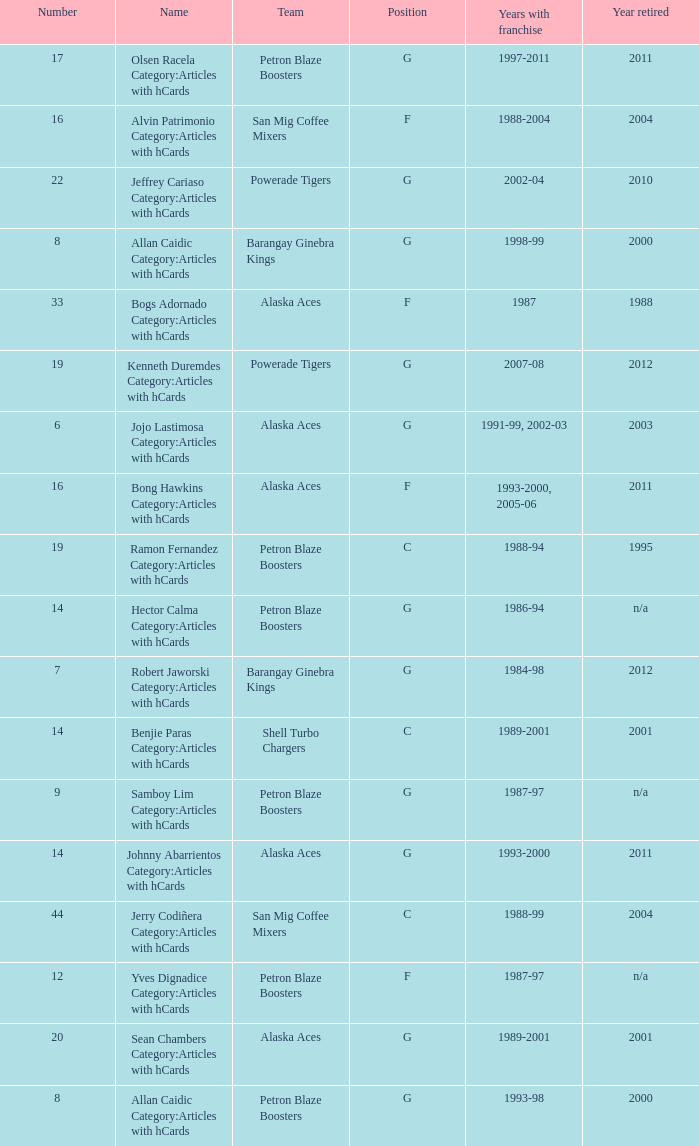How many years did the team in slot number 9 have a franchise? 1987-97. 